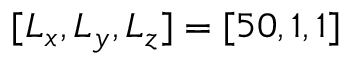Convert formula to latex. <formula><loc_0><loc_0><loc_500><loc_500>[ L _ { x } , L _ { y } , L _ { z } ] = [ 5 0 , 1 , 1 ]</formula> 